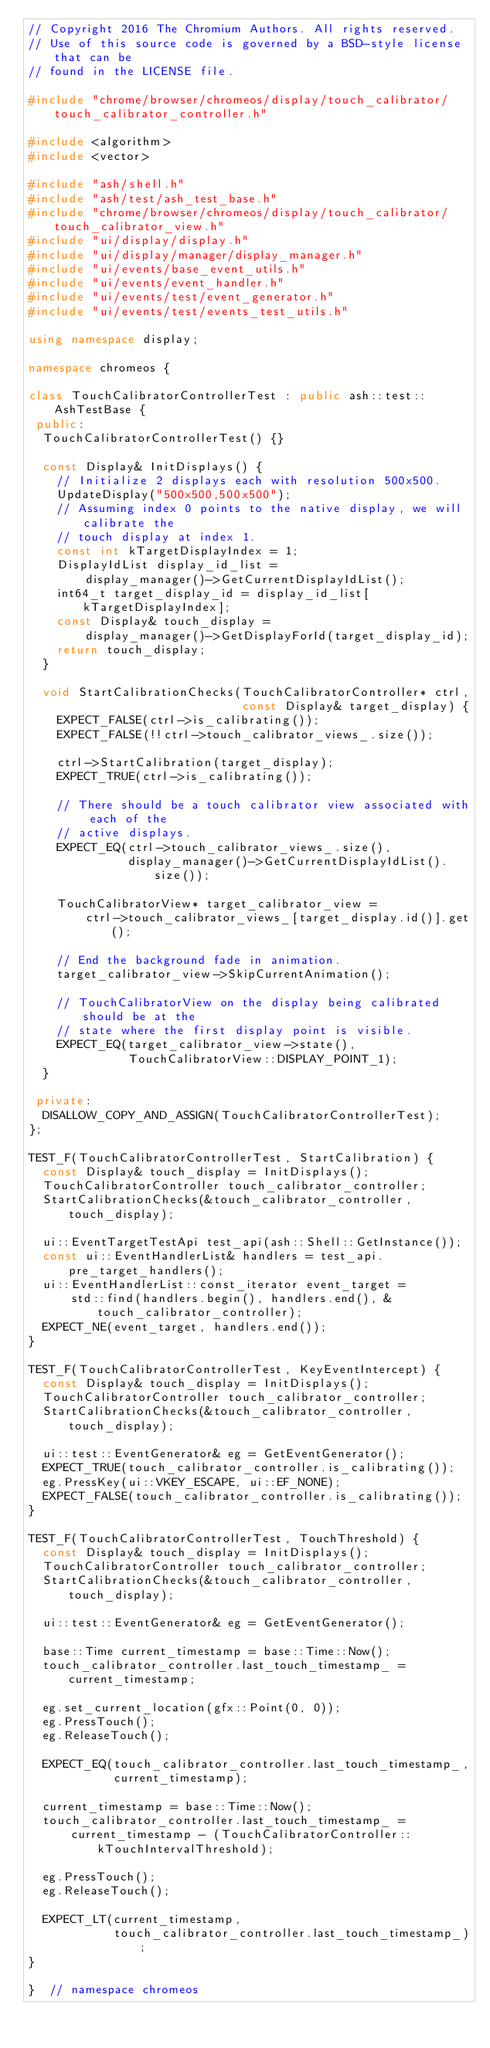<code> <loc_0><loc_0><loc_500><loc_500><_C++_>// Copyright 2016 The Chromium Authors. All rights reserved.
// Use of this source code is governed by a BSD-style license that can be
// found in the LICENSE file.

#include "chrome/browser/chromeos/display/touch_calibrator/touch_calibrator_controller.h"

#include <algorithm>
#include <vector>

#include "ash/shell.h"
#include "ash/test/ash_test_base.h"
#include "chrome/browser/chromeos/display/touch_calibrator/touch_calibrator_view.h"
#include "ui/display/display.h"
#include "ui/display/manager/display_manager.h"
#include "ui/events/base_event_utils.h"
#include "ui/events/event_handler.h"
#include "ui/events/test/event_generator.h"
#include "ui/events/test/events_test_utils.h"

using namespace display;

namespace chromeos {

class TouchCalibratorControllerTest : public ash::test::AshTestBase {
 public:
  TouchCalibratorControllerTest() {}

  const Display& InitDisplays() {
    // Initialize 2 displays each with resolution 500x500.
    UpdateDisplay("500x500,500x500");
    // Assuming index 0 points to the native display, we will calibrate the
    // touch display at index 1.
    const int kTargetDisplayIndex = 1;
    DisplayIdList display_id_list =
        display_manager()->GetCurrentDisplayIdList();
    int64_t target_display_id = display_id_list[kTargetDisplayIndex];
    const Display& touch_display =
        display_manager()->GetDisplayForId(target_display_id);
    return touch_display;
  }

  void StartCalibrationChecks(TouchCalibratorController* ctrl,
                              const Display& target_display) {
    EXPECT_FALSE(ctrl->is_calibrating());
    EXPECT_FALSE(!!ctrl->touch_calibrator_views_.size());

    ctrl->StartCalibration(target_display);
    EXPECT_TRUE(ctrl->is_calibrating());

    // There should be a touch calibrator view associated with each of the
    // active displays.
    EXPECT_EQ(ctrl->touch_calibrator_views_.size(),
              display_manager()->GetCurrentDisplayIdList().size());

    TouchCalibratorView* target_calibrator_view =
        ctrl->touch_calibrator_views_[target_display.id()].get();

    // End the background fade in animation.
    target_calibrator_view->SkipCurrentAnimation();

    // TouchCalibratorView on the display being calibrated should be at the
    // state where the first display point is visible.
    EXPECT_EQ(target_calibrator_view->state(),
              TouchCalibratorView::DISPLAY_POINT_1);
  }

 private:
  DISALLOW_COPY_AND_ASSIGN(TouchCalibratorControllerTest);
};

TEST_F(TouchCalibratorControllerTest, StartCalibration) {
  const Display& touch_display = InitDisplays();
  TouchCalibratorController touch_calibrator_controller;
  StartCalibrationChecks(&touch_calibrator_controller, touch_display);

  ui::EventTargetTestApi test_api(ash::Shell::GetInstance());
  const ui::EventHandlerList& handlers = test_api.pre_target_handlers();
  ui::EventHandlerList::const_iterator event_target =
      std::find(handlers.begin(), handlers.end(), &touch_calibrator_controller);
  EXPECT_NE(event_target, handlers.end());
}

TEST_F(TouchCalibratorControllerTest, KeyEventIntercept) {
  const Display& touch_display = InitDisplays();
  TouchCalibratorController touch_calibrator_controller;
  StartCalibrationChecks(&touch_calibrator_controller, touch_display);

  ui::test::EventGenerator& eg = GetEventGenerator();
  EXPECT_TRUE(touch_calibrator_controller.is_calibrating());
  eg.PressKey(ui::VKEY_ESCAPE, ui::EF_NONE);
  EXPECT_FALSE(touch_calibrator_controller.is_calibrating());
}

TEST_F(TouchCalibratorControllerTest, TouchThreshold) {
  const Display& touch_display = InitDisplays();
  TouchCalibratorController touch_calibrator_controller;
  StartCalibrationChecks(&touch_calibrator_controller, touch_display);

  ui::test::EventGenerator& eg = GetEventGenerator();

  base::Time current_timestamp = base::Time::Now();
  touch_calibrator_controller.last_touch_timestamp_ = current_timestamp;

  eg.set_current_location(gfx::Point(0, 0));
  eg.PressTouch();
  eg.ReleaseTouch();

  EXPECT_EQ(touch_calibrator_controller.last_touch_timestamp_,
            current_timestamp);

  current_timestamp = base::Time::Now();
  touch_calibrator_controller.last_touch_timestamp_ =
      current_timestamp - (TouchCalibratorController::kTouchIntervalThreshold);

  eg.PressTouch();
  eg.ReleaseTouch();

  EXPECT_LT(current_timestamp,
            touch_calibrator_controller.last_touch_timestamp_);
}

}  // namespace chromeos
</code> 